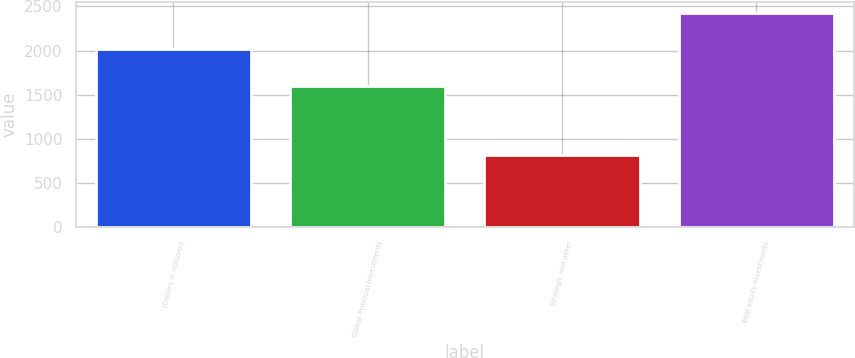Convert chart. <chart><loc_0><loc_0><loc_500><loc_500><bar_chart><fcel>(Dollars in millions)<fcel>Global Principal Investments<fcel>Strategic and other<fcel>Total equity investments<nl><fcel>2013<fcel>1604<fcel>822<fcel>2426<nl></chart> 